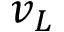<formula> <loc_0><loc_0><loc_500><loc_500>v _ { L }</formula> 